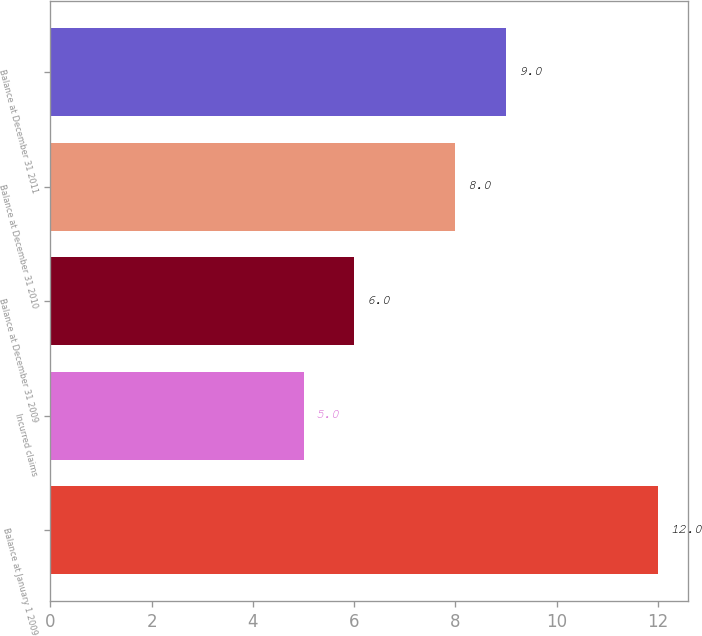Convert chart to OTSL. <chart><loc_0><loc_0><loc_500><loc_500><bar_chart><fcel>Balance at January 1 2009<fcel>Incurred claims<fcel>Balance at December 31 2009<fcel>Balance at December 31 2010<fcel>Balance at December 31 2011<nl><fcel>12<fcel>5<fcel>6<fcel>8<fcel>9<nl></chart> 